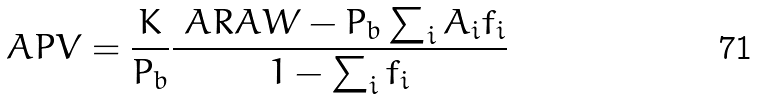Convert formula to latex. <formula><loc_0><loc_0><loc_500><loc_500>\ A P V = \frac { K } { P _ { b } } \frac { \ A R A W - P _ { b } \sum _ { i } A _ { i } f _ { i } } { 1 - \sum _ { i } f _ { i } }</formula> 